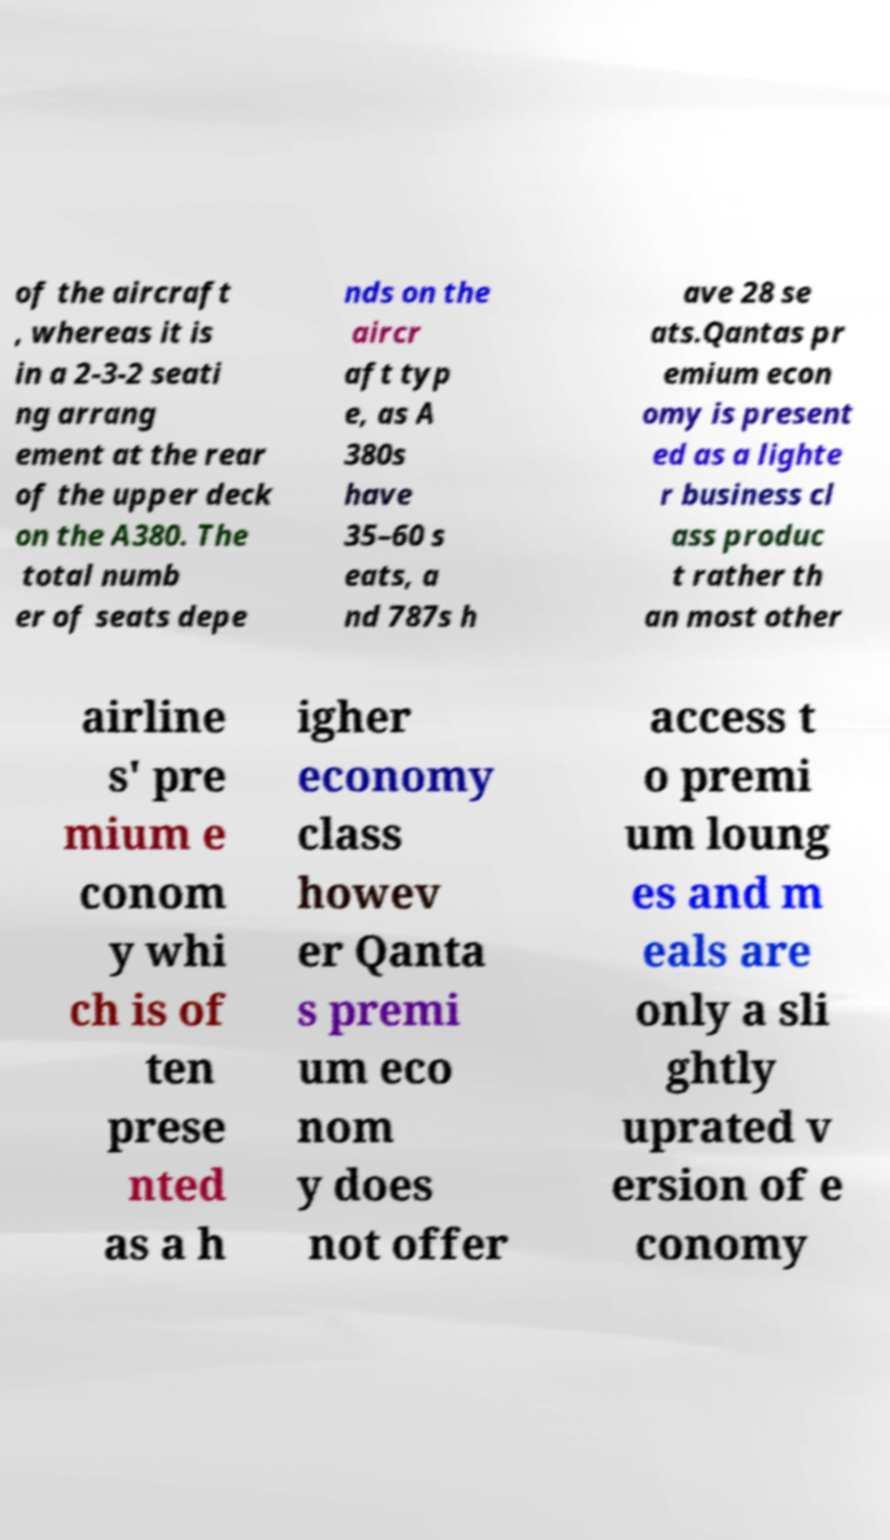Please identify and transcribe the text found in this image. of the aircraft , whereas it is in a 2-3-2 seati ng arrang ement at the rear of the upper deck on the A380. The total numb er of seats depe nds on the aircr aft typ e, as A 380s have 35–60 s eats, a nd 787s h ave 28 se ats.Qantas pr emium econ omy is present ed as a lighte r business cl ass produc t rather th an most other airline s' pre mium e conom y whi ch is of ten prese nted as a h igher economy class howev er Qanta s premi um eco nom y does not offer access t o premi um loung es and m eals are only a sli ghtly uprated v ersion of e conomy 